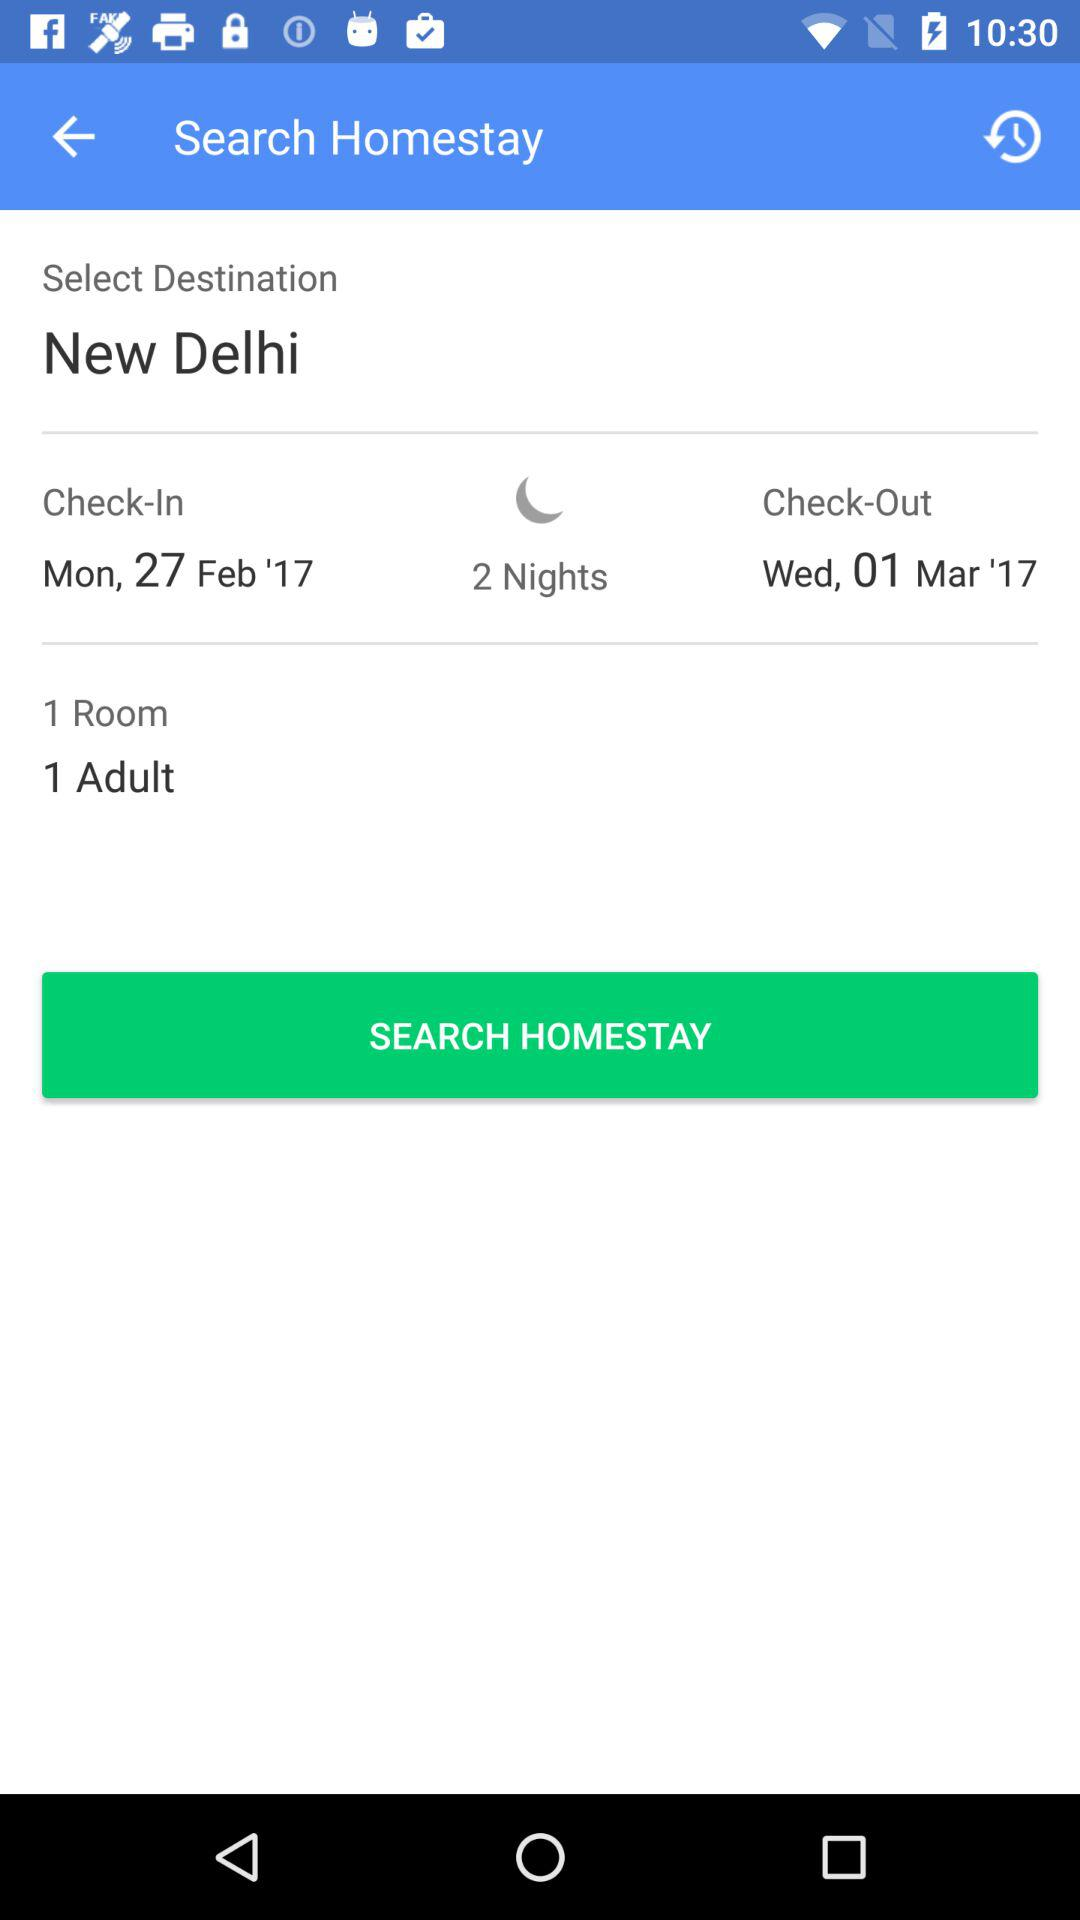What is the selected destination? The selected destination is New Delhi. 